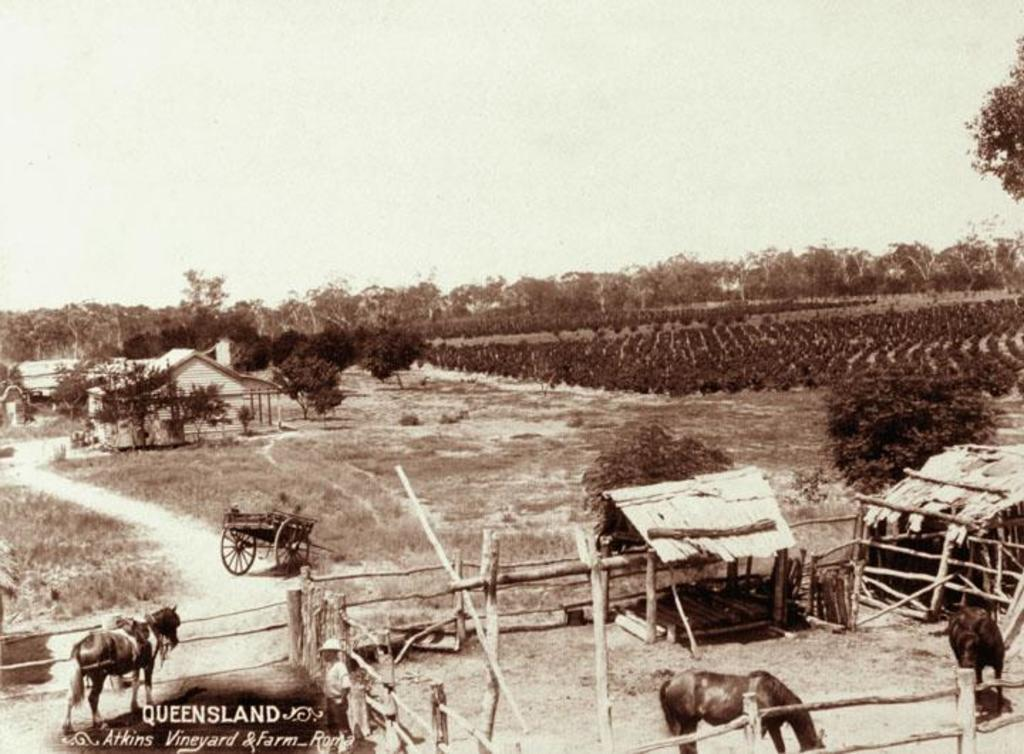What type of image is present in the picture? There is an old photograph in the image. What animals can be seen in the photograph? The photograph contains horses. What mode of transportation is depicted in the photograph? The photograph contains bullock carts. What type of barrier can be seen in the photograph? The photograph contains a wooden fence. What type of dwelling is visible in the photograph? The photograph contains grass huts. What type of vegetation is present in the photograph? The photograph contains trees. What type of agricultural activity is shown in the photograph? The photograph contains crops. What type of sock is visible on the elbow of the person in the image? There is no person visible in the image, and therefore no sock or elbow can be observed. 